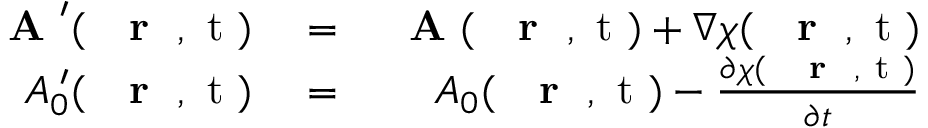<formula> <loc_0><loc_0><loc_500><loc_500>\begin{array} { r l r } { A ^ { \prime } ( { r } , t ) } & = } & { A ( { r } , t ) + \nabla \chi ( { r } , t ) } \\ { A _ { 0 } ^ { \, \prime } ( { r } , t ) } & = } & { A _ { 0 } ( { r } , t ) - \frac { \partial \chi ( { r } , t ) } { \partial t } } \end{array}</formula> 